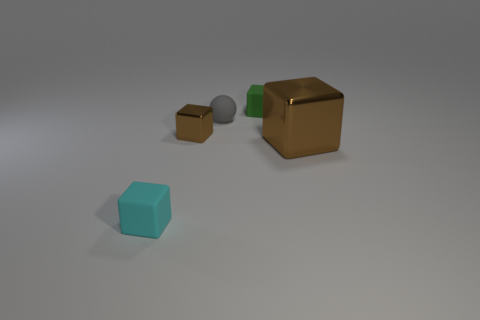Subtract all yellow blocks. Subtract all brown cylinders. How many blocks are left? 4 Add 2 big gray blocks. How many objects exist? 7 Subtract all balls. How many objects are left? 4 Subtract 0 yellow balls. How many objects are left? 5 Subtract all cyan matte things. Subtract all large shiny cubes. How many objects are left? 3 Add 3 large metal cubes. How many large metal cubes are left? 4 Add 4 large yellow cylinders. How many large yellow cylinders exist? 4 